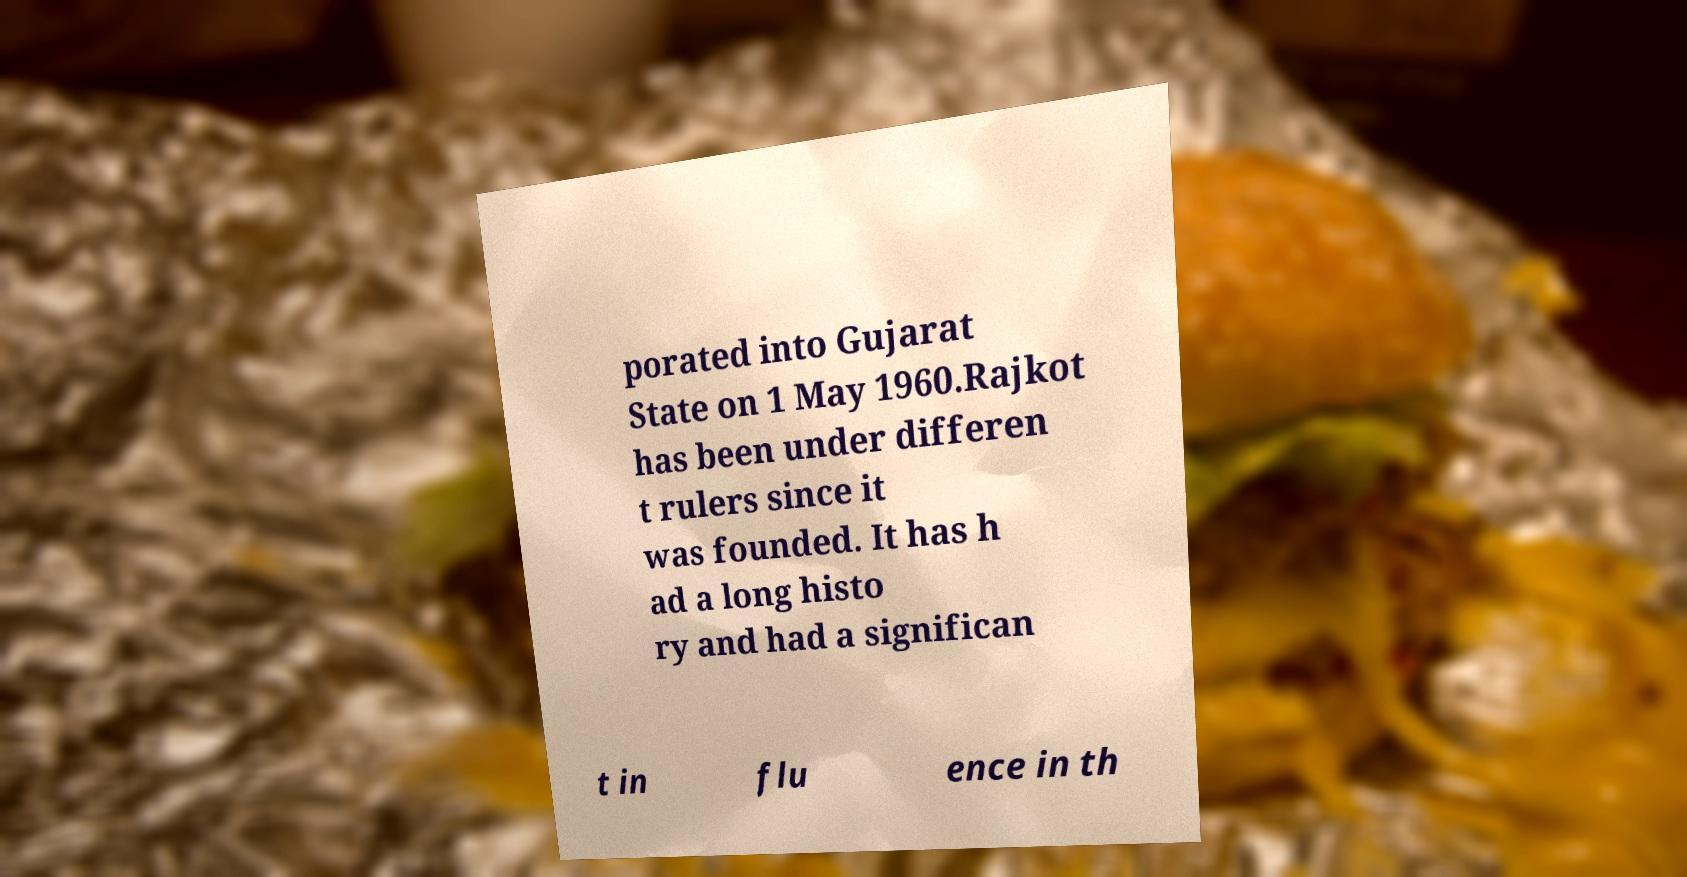Can you read and provide the text displayed in the image?This photo seems to have some interesting text. Can you extract and type it out for me? porated into Gujarat State on 1 May 1960.Rajkot has been under differen t rulers since it was founded. It has h ad a long histo ry and had a significan t in flu ence in th 